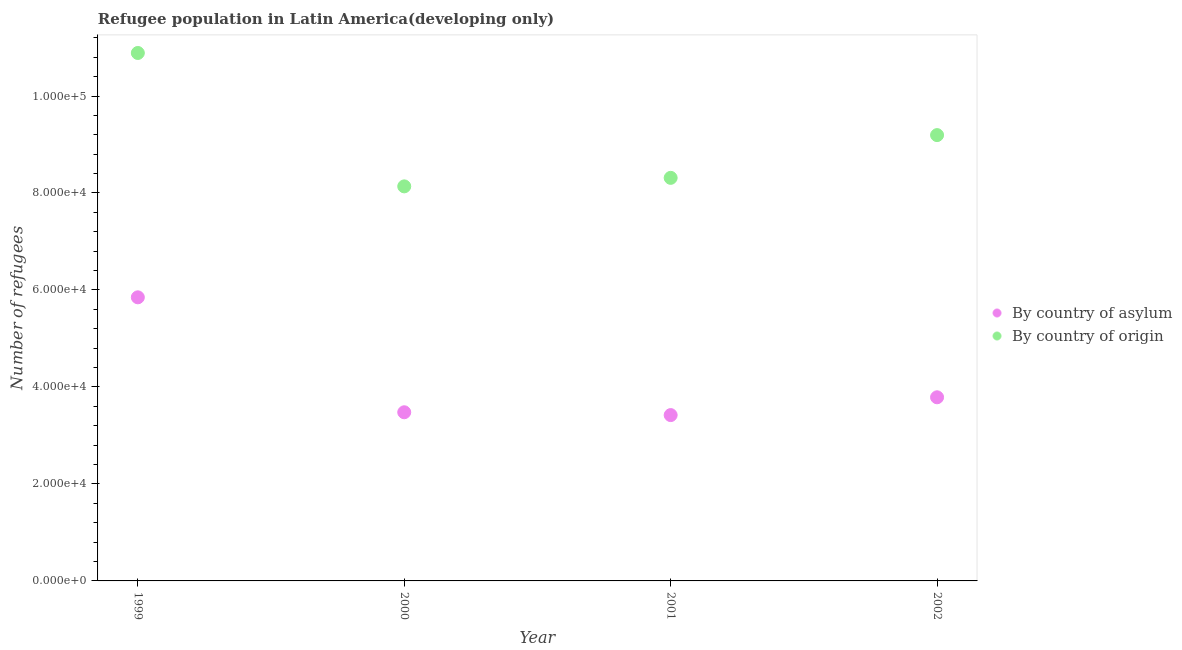How many different coloured dotlines are there?
Your answer should be very brief. 2. Is the number of dotlines equal to the number of legend labels?
Offer a terse response. Yes. What is the number of refugees by country of asylum in 2002?
Give a very brief answer. 3.79e+04. Across all years, what is the maximum number of refugees by country of asylum?
Offer a terse response. 5.85e+04. Across all years, what is the minimum number of refugees by country of asylum?
Provide a short and direct response. 3.42e+04. In which year was the number of refugees by country of asylum minimum?
Provide a short and direct response. 2001. What is the total number of refugees by country of asylum in the graph?
Keep it short and to the point. 1.65e+05. What is the difference between the number of refugees by country of origin in 2000 and that in 2001?
Your answer should be compact. -1758. What is the difference between the number of refugees by country of origin in 2001 and the number of refugees by country of asylum in 1999?
Your answer should be very brief. 2.46e+04. What is the average number of refugees by country of asylum per year?
Ensure brevity in your answer.  4.13e+04. In the year 2001, what is the difference between the number of refugees by country of asylum and number of refugees by country of origin?
Your answer should be very brief. -4.89e+04. What is the ratio of the number of refugees by country of asylum in 2000 to that in 2002?
Provide a short and direct response. 0.92. What is the difference between the highest and the second highest number of refugees by country of asylum?
Your answer should be compact. 2.06e+04. What is the difference between the highest and the lowest number of refugees by country of origin?
Your answer should be very brief. 2.75e+04. In how many years, is the number of refugees by country of asylum greater than the average number of refugees by country of asylum taken over all years?
Offer a very short reply. 1. Does the number of refugees by country of asylum monotonically increase over the years?
Your response must be concise. No. Is the number of refugees by country of asylum strictly less than the number of refugees by country of origin over the years?
Keep it short and to the point. Yes. How many dotlines are there?
Provide a succinct answer. 2. What is the difference between two consecutive major ticks on the Y-axis?
Provide a succinct answer. 2.00e+04. Are the values on the major ticks of Y-axis written in scientific E-notation?
Provide a succinct answer. Yes. Does the graph contain grids?
Your answer should be compact. No. How are the legend labels stacked?
Your answer should be compact. Vertical. What is the title of the graph?
Offer a very short reply. Refugee population in Latin America(developing only). What is the label or title of the X-axis?
Ensure brevity in your answer.  Year. What is the label or title of the Y-axis?
Provide a short and direct response. Number of refugees. What is the Number of refugees in By country of asylum in 1999?
Your response must be concise. 5.85e+04. What is the Number of refugees of By country of origin in 1999?
Provide a short and direct response. 1.09e+05. What is the Number of refugees of By country of asylum in 2000?
Provide a short and direct response. 3.48e+04. What is the Number of refugees in By country of origin in 2000?
Keep it short and to the point. 8.14e+04. What is the Number of refugees in By country of asylum in 2001?
Your answer should be compact. 3.42e+04. What is the Number of refugees in By country of origin in 2001?
Make the answer very short. 8.31e+04. What is the Number of refugees of By country of asylum in 2002?
Your response must be concise. 3.79e+04. What is the Number of refugees of By country of origin in 2002?
Give a very brief answer. 9.19e+04. Across all years, what is the maximum Number of refugees of By country of asylum?
Your response must be concise. 5.85e+04. Across all years, what is the maximum Number of refugees in By country of origin?
Your answer should be very brief. 1.09e+05. Across all years, what is the minimum Number of refugees of By country of asylum?
Your answer should be compact. 3.42e+04. Across all years, what is the minimum Number of refugees in By country of origin?
Provide a short and direct response. 8.14e+04. What is the total Number of refugees of By country of asylum in the graph?
Your answer should be compact. 1.65e+05. What is the total Number of refugees of By country of origin in the graph?
Keep it short and to the point. 3.65e+05. What is the difference between the Number of refugees in By country of asylum in 1999 and that in 2000?
Your answer should be very brief. 2.37e+04. What is the difference between the Number of refugees of By country of origin in 1999 and that in 2000?
Your answer should be very brief. 2.75e+04. What is the difference between the Number of refugees of By country of asylum in 1999 and that in 2001?
Provide a succinct answer. 2.43e+04. What is the difference between the Number of refugees of By country of origin in 1999 and that in 2001?
Offer a very short reply. 2.58e+04. What is the difference between the Number of refugees in By country of asylum in 1999 and that in 2002?
Give a very brief answer. 2.06e+04. What is the difference between the Number of refugees of By country of origin in 1999 and that in 2002?
Offer a terse response. 1.69e+04. What is the difference between the Number of refugees in By country of asylum in 2000 and that in 2001?
Provide a succinct answer. 583. What is the difference between the Number of refugees of By country of origin in 2000 and that in 2001?
Ensure brevity in your answer.  -1758. What is the difference between the Number of refugees in By country of asylum in 2000 and that in 2002?
Give a very brief answer. -3089. What is the difference between the Number of refugees in By country of origin in 2000 and that in 2002?
Your answer should be very brief. -1.06e+04. What is the difference between the Number of refugees in By country of asylum in 2001 and that in 2002?
Ensure brevity in your answer.  -3672. What is the difference between the Number of refugees of By country of origin in 2001 and that in 2002?
Your response must be concise. -8815. What is the difference between the Number of refugees of By country of asylum in 1999 and the Number of refugees of By country of origin in 2000?
Your answer should be compact. -2.29e+04. What is the difference between the Number of refugees of By country of asylum in 1999 and the Number of refugees of By country of origin in 2001?
Keep it short and to the point. -2.46e+04. What is the difference between the Number of refugees in By country of asylum in 1999 and the Number of refugees in By country of origin in 2002?
Make the answer very short. -3.35e+04. What is the difference between the Number of refugees of By country of asylum in 2000 and the Number of refugees of By country of origin in 2001?
Offer a terse response. -4.83e+04. What is the difference between the Number of refugees in By country of asylum in 2000 and the Number of refugees in By country of origin in 2002?
Provide a short and direct response. -5.72e+04. What is the difference between the Number of refugees in By country of asylum in 2001 and the Number of refugees in By country of origin in 2002?
Make the answer very short. -5.77e+04. What is the average Number of refugees in By country of asylum per year?
Keep it short and to the point. 4.13e+04. What is the average Number of refugees in By country of origin per year?
Your answer should be compact. 9.13e+04. In the year 1999, what is the difference between the Number of refugees of By country of asylum and Number of refugees of By country of origin?
Your response must be concise. -5.04e+04. In the year 2000, what is the difference between the Number of refugees of By country of asylum and Number of refugees of By country of origin?
Make the answer very short. -4.66e+04. In the year 2001, what is the difference between the Number of refugees of By country of asylum and Number of refugees of By country of origin?
Ensure brevity in your answer.  -4.89e+04. In the year 2002, what is the difference between the Number of refugees of By country of asylum and Number of refugees of By country of origin?
Your answer should be compact. -5.41e+04. What is the ratio of the Number of refugees in By country of asylum in 1999 to that in 2000?
Offer a very short reply. 1.68. What is the ratio of the Number of refugees of By country of origin in 1999 to that in 2000?
Keep it short and to the point. 1.34. What is the ratio of the Number of refugees in By country of asylum in 1999 to that in 2001?
Provide a succinct answer. 1.71. What is the ratio of the Number of refugees of By country of origin in 1999 to that in 2001?
Keep it short and to the point. 1.31. What is the ratio of the Number of refugees of By country of asylum in 1999 to that in 2002?
Your response must be concise. 1.54. What is the ratio of the Number of refugees in By country of origin in 1999 to that in 2002?
Give a very brief answer. 1.18. What is the ratio of the Number of refugees in By country of asylum in 2000 to that in 2001?
Your answer should be compact. 1.02. What is the ratio of the Number of refugees in By country of origin in 2000 to that in 2001?
Give a very brief answer. 0.98. What is the ratio of the Number of refugees in By country of asylum in 2000 to that in 2002?
Offer a terse response. 0.92. What is the ratio of the Number of refugees in By country of origin in 2000 to that in 2002?
Give a very brief answer. 0.89. What is the ratio of the Number of refugees of By country of asylum in 2001 to that in 2002?
Offer a very short reply. 0.9. What is the ratio of the Number of refugees of By country of origin in 2001 to that in 2002?
Make the answer very short. 0.9. What is the difference between the highest and the second highest Number of refugees in By country of asylum?
Ensure brevity in your answer.  2.06e+04. What is the difference between the highest and the second highest Number of refugees of By country of origin?
Keep it short and to the point. 1.69e+04. What is the difference between the highest and the lowest Number of refugees of By country of asylum?
Offer a terse response. 2.43e+04. What is the difference between the highest and the lowest Number of refugees in By country of origin?
Make the answer very short. 2.75e+04. 